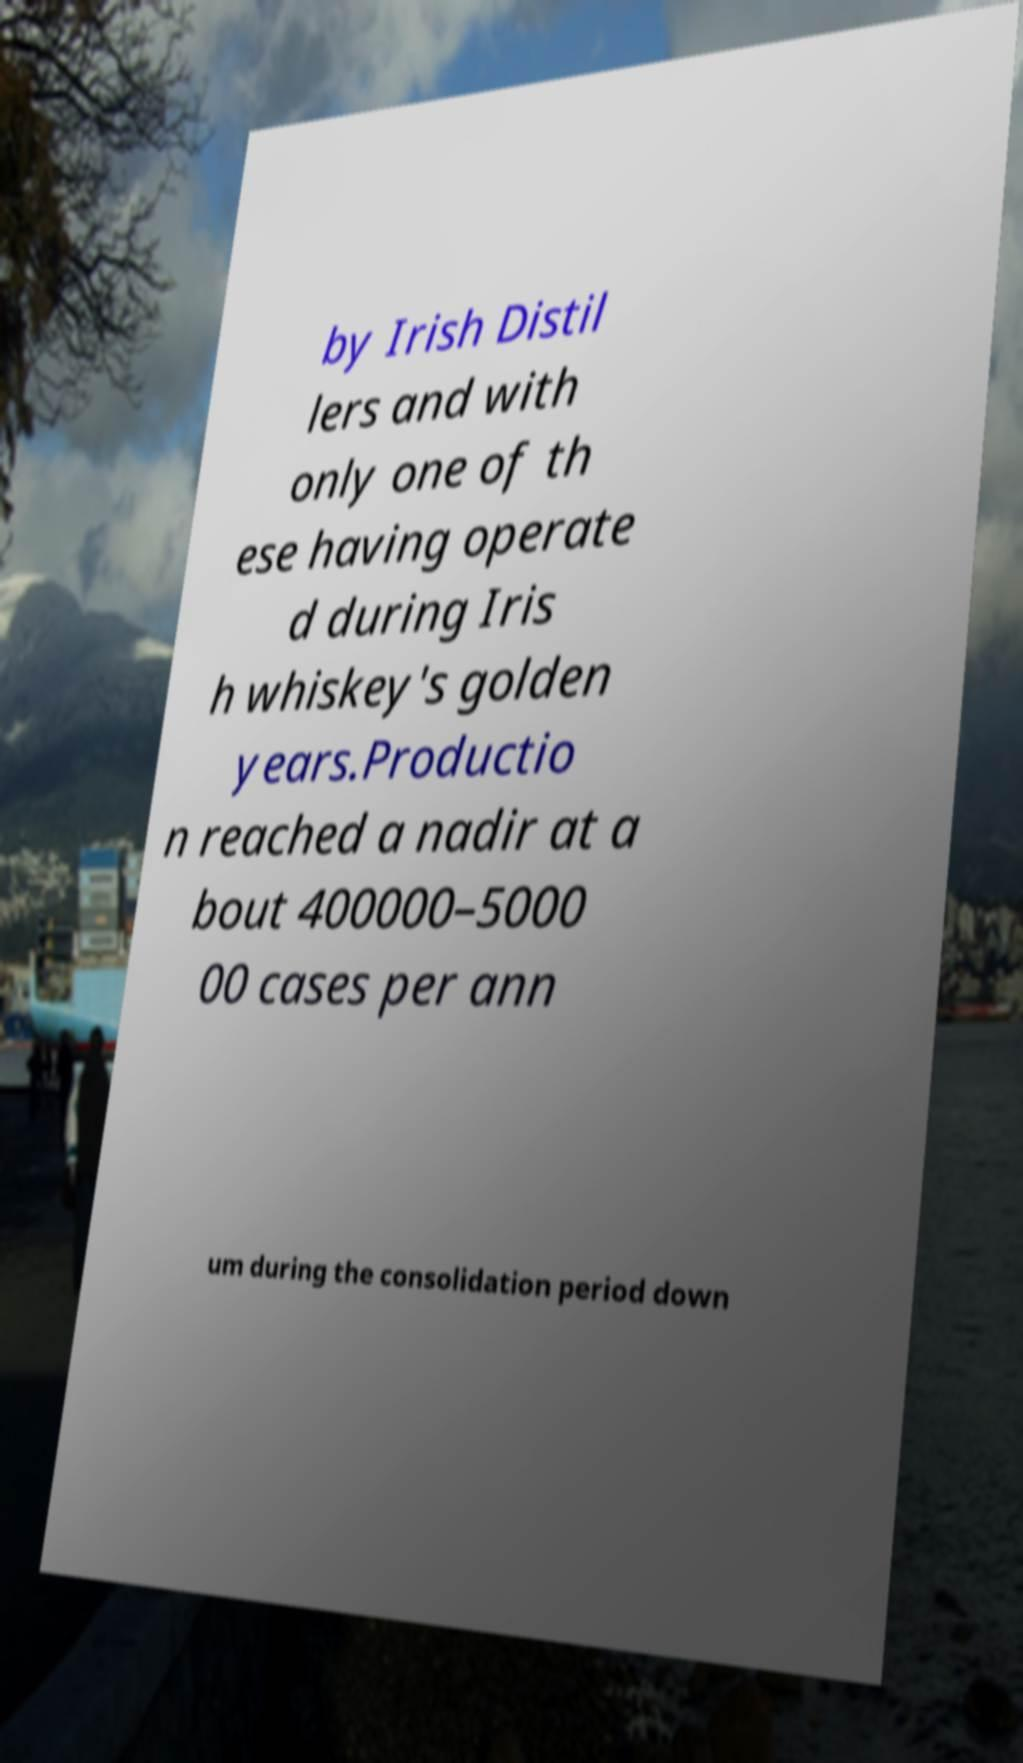For documentation purposes, I need the text within this image transcribed. Could you provide that? by Irish Distil lers and with only one of th ese having operate d during Iris h whiskey's golden years.Productio n reached a nadir at a bout 400000–5000 00 cases per ann um during the consolidation period down 